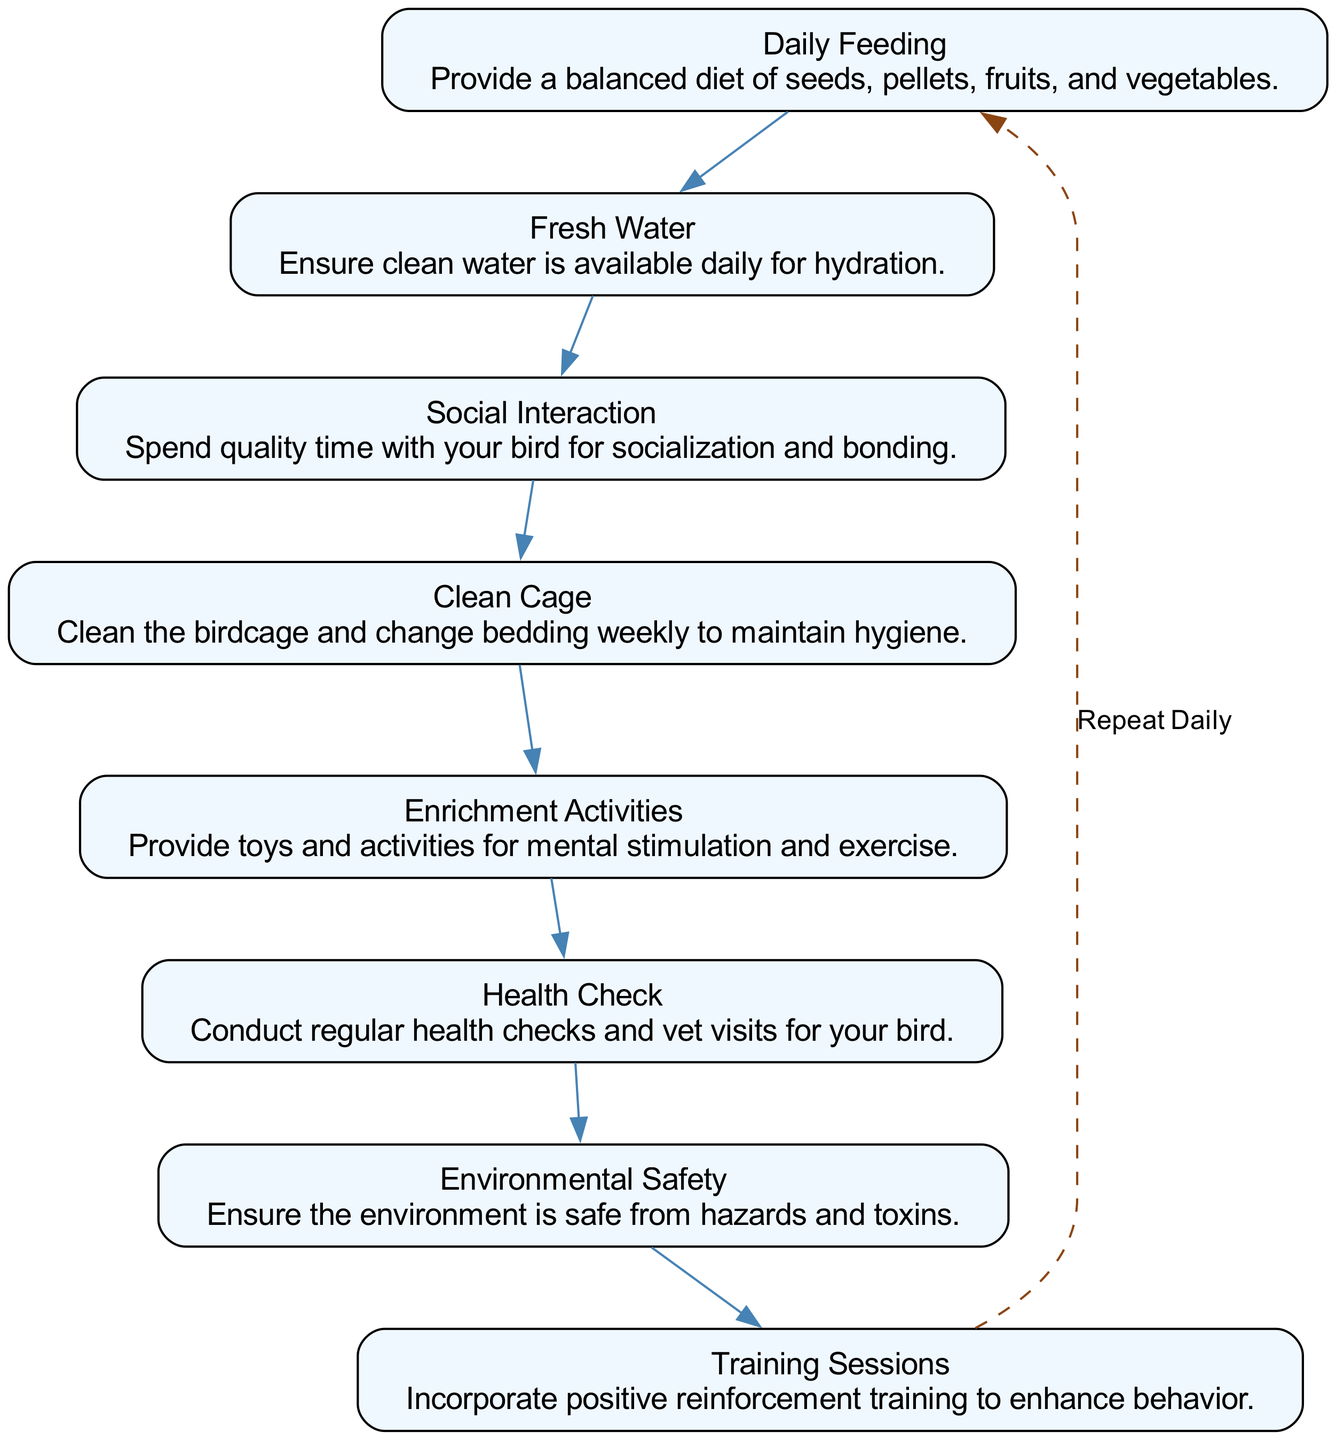What is the first step in the bird care routine? The first step shown in the diagram is "Daily Feeding," indicated at the top of the flow chart.
Answer: Daily Feeding How many main steps are displayed in the care routine? There are a total of eight main steps represented in the diagram.
Answer: Eight What is the last step before the cycle repeats? The last step before the repeating cycle is "Training Sessions." It's positioned just before the dashed edge that cycles back to "Daily Feeding."
Answer: Training Sessions Which step emphasizes social interaction with the bird? The step that emphasizes social interaction is "Social Interaction," specifically highlighting the importance of bonding time.
Answer: Social Interaction What is indicated by the dashed edge in the diagram? The dashed edge indicates that the sequence of steps should be repeated daily, connecting back to the first step.
Answer: Repeat Daily What is the importance of the "Environmental Safety" step? The diagram shows "Environmental Safety" to highlight the need for a hazard-free living space for the bird.
Answer: Environmental Safety How are the enrichment activities related to the overall care routine? Enrichment activities are part of the routine to provide mental stimulation and exercise for the bird, promoting overall well-being.
Answer: Mental stimulation What should be done regarding the bird's health? The care routine includes conducting regular health checks and scheduling vet visits to ensure the bird's health.
Answer: Health Check 